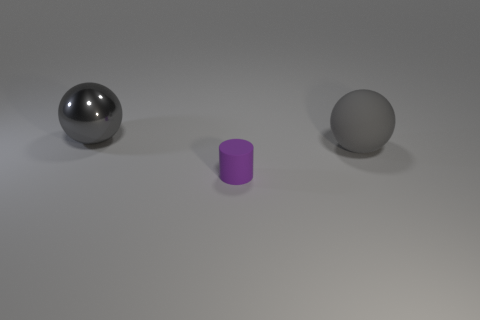Add 2 big metallic balls. How many objects exist? 5 Subtract all spheres. How many objects are left? 1 Add 3 metallic spheres. How many metallic spheres are left? 4 Add 1 big matte balls. How many big matte balls exist? 2 Subtract 0 green cubes. How many objects are left? 3 Subtract all large brown matte cylinders. Subtract all tiny matte cylinders. How many objects are left? 2 